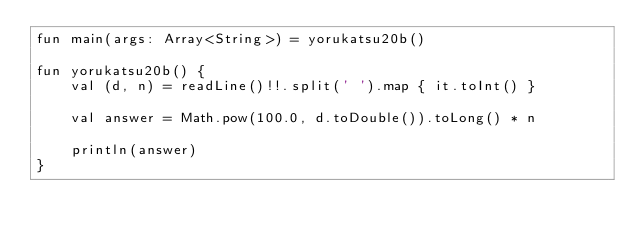Convert code to text. <code><loc_0><loc_0><loc_500><loc_500><_Kotlin_>fun main(args: Array<String>) = yorukatsu20b()

fun yorukatsu20b() {
    val (d, n) = readLine()!!.split(' ').map { it.toInt() }

    val answer = Math.pow(100.0, d.toDouble()).toLong() * n

    println(answer)
}
</code> 